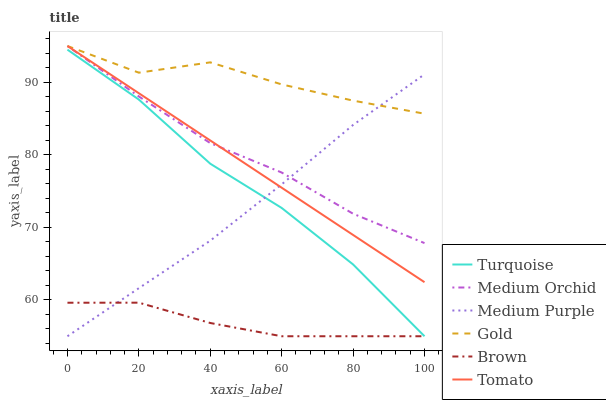Does Brown have the minimum area under the curve?
Answer yes or no. Yes. Does Gold have the maximum area under the curve?
Answer yes or no. Yes. Does Turquoise have the minimum area under the curve?
Answer yes or no. No. Does Turquoise have the maximum area under the curve?
Answer yes or no. No. Is Tomato the smoothest?
Answer yes or no. Yes. Is Gold the roughest?
Answer yes or no. Yes. Is Brown the smoothest?
Answer yes or no. No. Is Brown the roughest?
Answer yes or no. No. Does Brown have the lowest value?
Answer yes or no. Yes. Does Gold have the lowest value?
Answer yes or no. No. Does Medium Orchid have the highest value?
Answer yes or no. Yes. Does Turquoise have the highest value?
Answer yes or no. No. Is Turquoise less than Medium Orchid?
Answer yes or no. Yes. Is Gold greater than Brown?
Answer yes or no. Yes. Does Tomato intersect Medium Purple?
Answer yes or no. Yes. Is Tomato less than Medium Purple?
Answer yes or no. No. Is Tomato greater than Medium Purple?
Answer yes or no. No. Does Turquoise intersect Medium Orchid?
Answer yes or no. No. 